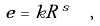Convert formula to latex. <formula><loc_0><loc_0><loc_500><loc_500>e = k R \, ^ { s } \ \ ,</formula> 